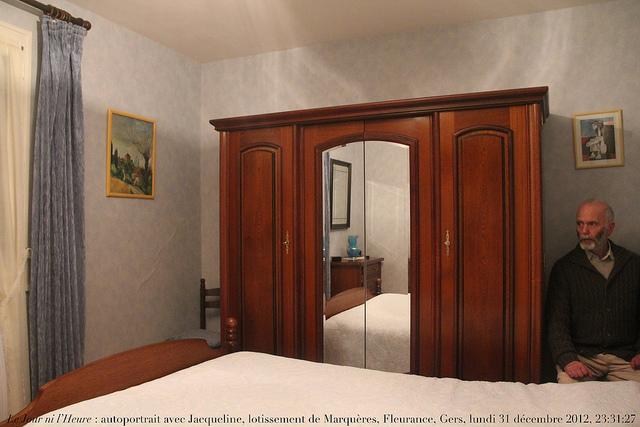What side of the mirror is the elderly man?
Answer briefly. Right. What color are the drapes?
Concise answer only. Blue. Where is the mirror?
Give a very brief answer. Cabinet. 